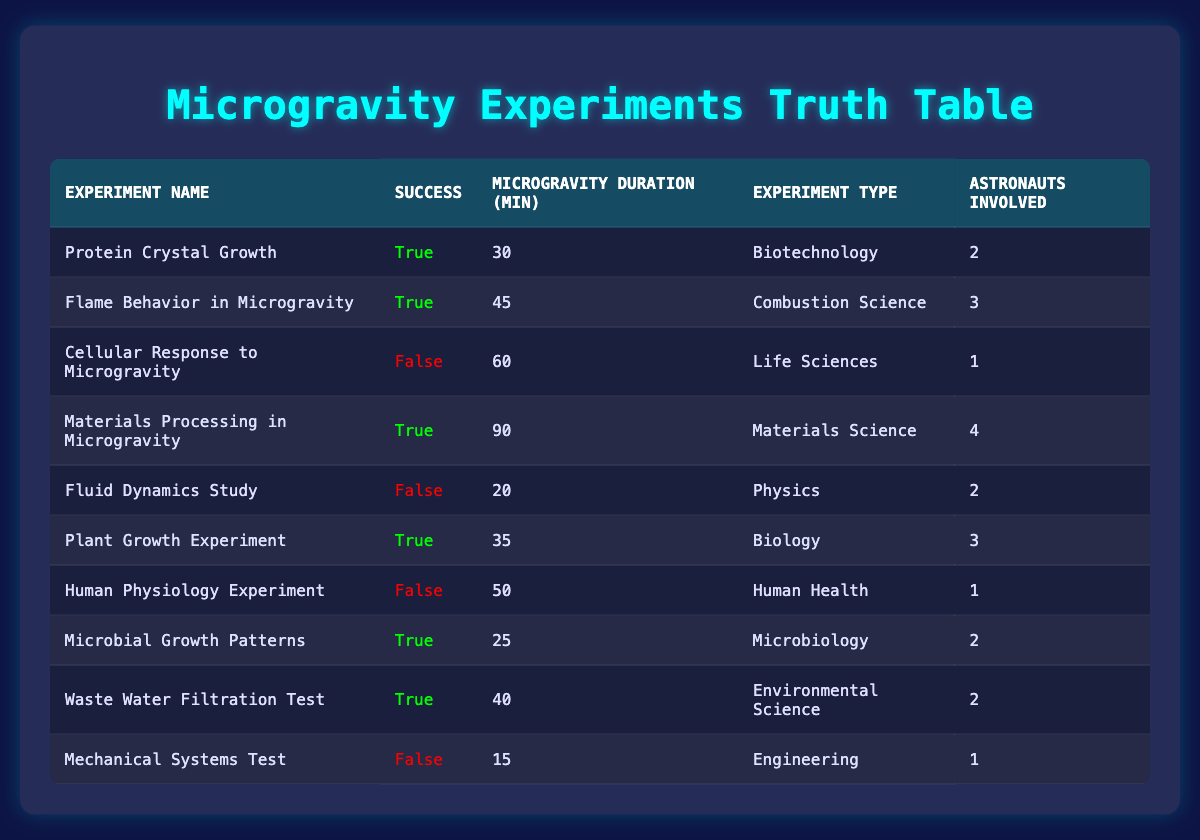What is the success rate of the experiments conducted? There are a total of 10 experiments listed. Out of these, 6 experiments were successful and 4 were not. The success rate can be calculated as (number of successful experiments / total experiments) × 100, which is (6 / 10) × 100 = 60%.
Answer: 60% Which experiment had the longest microgravity duration? Looking at the microgravity duration column, the longest duration listed is 90 minutes for the "Materials Processing in Microgravity" experiment.
Answer: 90 minutes How many experiments involved more than 2 astronauts? By checking the astronauts involved column, we see that only one experiment, "Materials Processing in Microgravity," involved 4 astronauts. Therefore, the count for experiments with more than 2 astronauts is 1.
Answer: 1 Is the "Fluid Dynamics Study" experiment successful? In the table under the success column, "Fluid Dynamics Study" is marked as false, indicating that the experiment was not successful.
Answer: No What is the average microgravity duration of successful experiments? We take the microgravity durations of successful experiments: 30 (Protein Crystal Growth) + 45 (Flame Behavior in Microgravity) + 90 (Materials Processing in Microgravity) + 35 (Plant Growth Experiment) + 25 (Microbial Growth Patterns) + 40 (Waste Water Filtration Test). The total is 30 + 45 + 90 + 35 + 25 + 40 = 265 minutes. There are 6 successful experiments, so the average duration is 265 / 6 = 44.17 minutes.
Answer: 44.17 minutes Which experiment category had the highest failure rate? To find the category with the highest failure rate, we look at the failed experiments: "Cellular Response to Microgravity," "Fluid Dynamics Study," "Human Physiology Experiment," and "Mechanical Systems Test." Counting the failures, we see that Life Sciences, Physics, Human Health, and Engineering each had one failure. They all have a failure rate of 100%. Since there are equal numbers, we can say they share this highest failure rate equally.
Answer: Life Sciences, Physics, Human Health, Engineering What is the success status of the "Waste Water Filtration Test"? The table indicates that the "Waste Water Filtration Test" is marked as true in the success column, meaning this experiment was successful.
Answer: Yes How many successful experiments were conducted in the field of Biology? From the provided data, the "Plant Growth Experiment" in the field of Biology is marked as successful (true). This indicates there is only 1 successful experiment in this category.
Answer: 1 